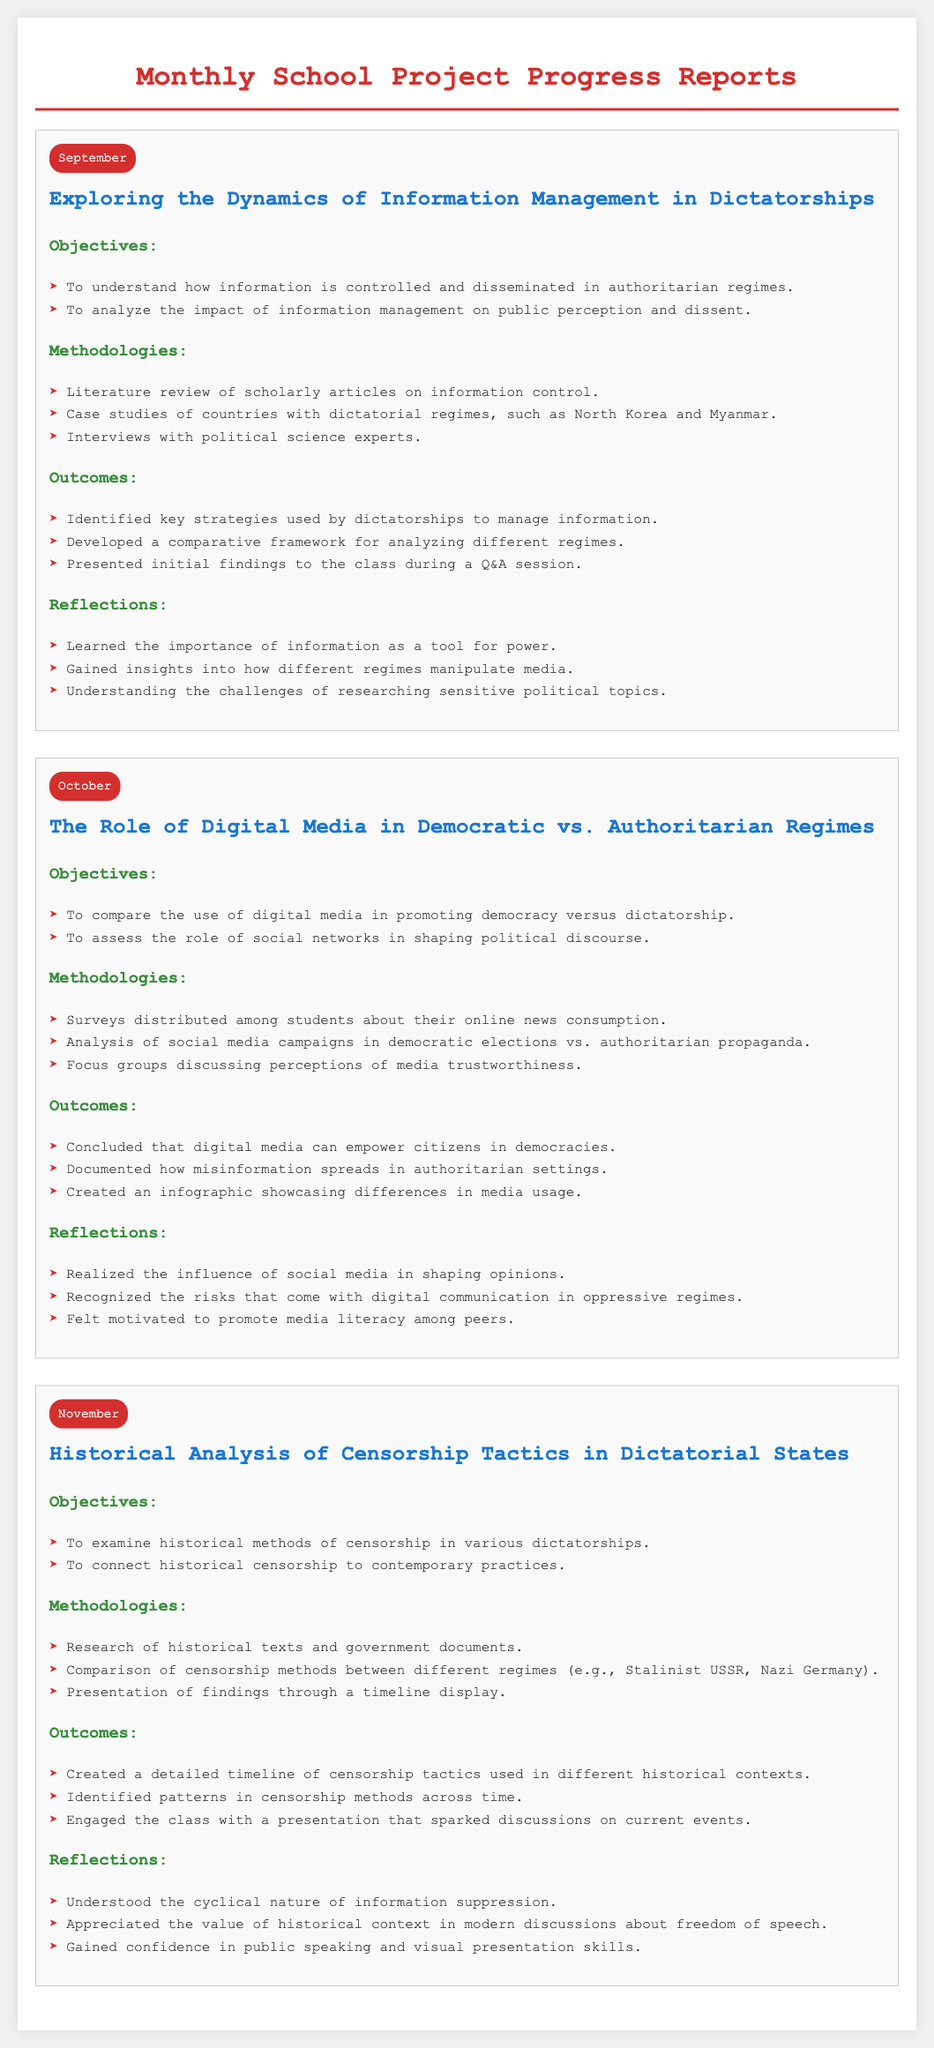What is the title of the September project? The title of the September project is stated under the corresponding month badge in the report.
Answer: Exploring the Dynamics of Information Management in Dictatorships What methodologies were used in the October project? The methodologies are listed in bullet points under the October project's section, highlighting specific research approaches.
Answer: Surveys, Analysis of social media campaigns, Focus groups What was one outcome of the September project? The outcomes are detailed in the report, outlining the results achieved during the September project.
Answer: Identified key strategies used by dictatorships to manage information How many projects are reported in total? The total number of projects can be counted from the sections labeled by month in the document.
Answer: Three What reflection was noted from the November project? The reflections are insights or learnings mentioned at the end of each project.
Answer: Understood the cyclical nature of information suppression What other regime was compared with Stalinist USSR in the November project? The comparison is indicated within the methodologies section of the November project, which specifies the regimes analyzed.
Answer: Nazi Germany In which month was the project about digital media conducted? The reports are organized by month, making it easy to identify the timing of each project.
Answer: October What was one objective of the September project? The objectives are specified under each project's section, outlining the goals of the research.
Answer: To understand how information is controlled and disseminated in authoritarian regimes 